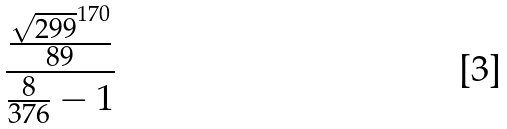Convert formula to latex. <formula><loc_0><loc_0><loc_500><loc_500>\frac { \frac { \sqrt { 2 9 9 } ^ { 1 7 0 } } { 8 9 } } { \frac { 8 } { 3 7 6 } - 1 }</formula> 